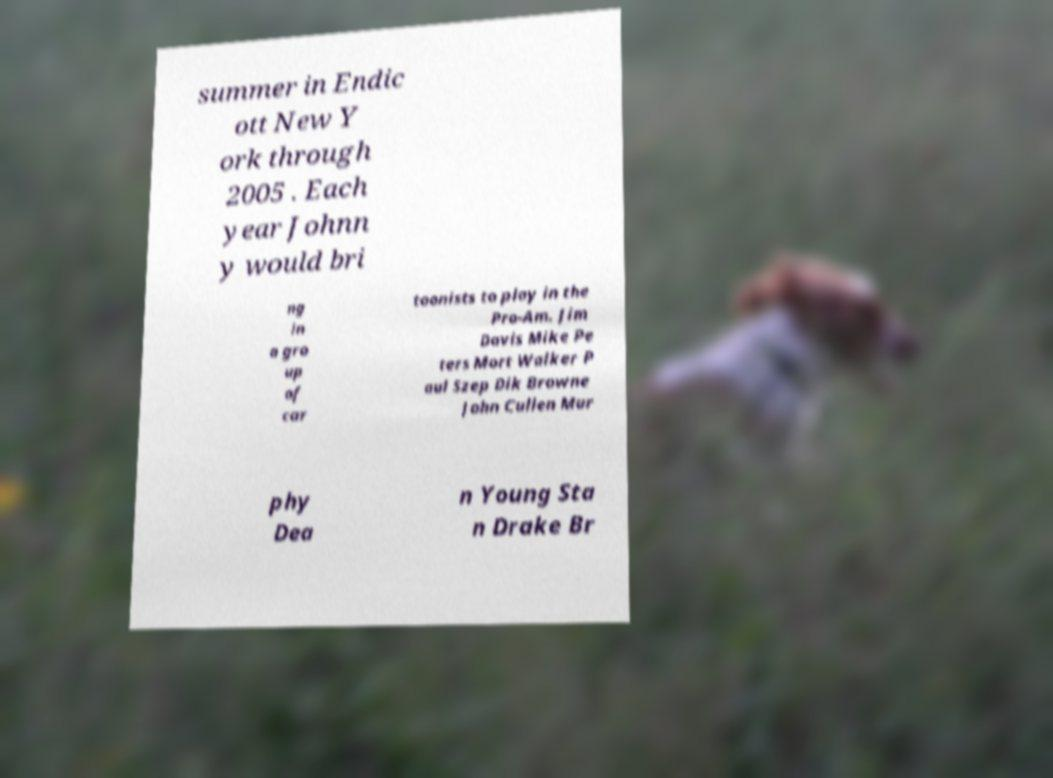Please read and relay the text visible in this image. What does it say? summer in Endic ott New Y ork through 2005 . Each year Johnn y would bri ng in a gro up of car toonists to play in the Pro-Am. Jim Davis Mike Pe ters Mort Walker P aul Szep Dik Browne John Cullen Mur phy Dea n Young Sta n Drake Br 